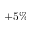<formula> <loc_0><loc_0><loc_500><loc_500>+ 5 \%</formula> 